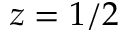<formula> <loc_0><loc_0><loc_500><loc_500>z = 1 / 2</formula> 